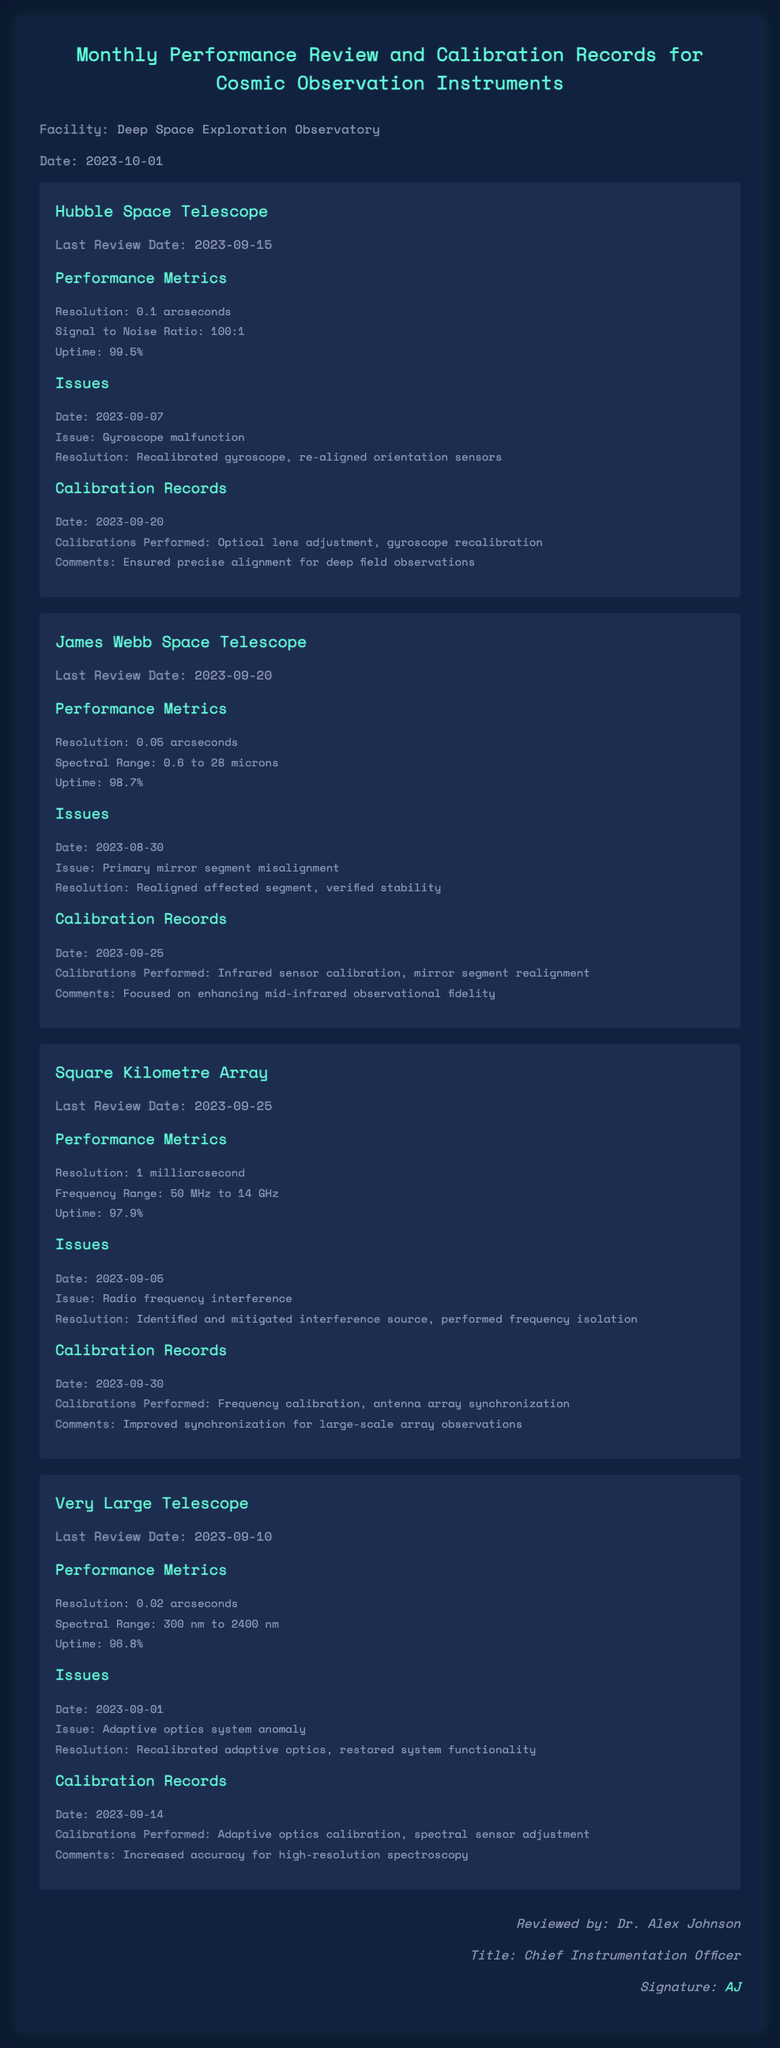What is the facility name? The facility name is explicitly mentioned at the beginning of the document.
Answer: Deep Space Exploration Observatory What is the uptime percentage of the Hubble Space Telescope? The uptime percentage is provided in the performance metrics section for the Hubble Space Telescope.
Answer: 99.5% What issue was reported for the James Webb Space Telescope? The issue reported is listed under the issues section for the James Webb Space Telescope.
Answer: Primary mirror segment misalignment What date was the calibration performed for the Very Large Telescope? The date of calibration can be found in the calibration records section for the Very Large Telescope.
Answer: 2023-09-14 Which instrument had a resolution of 1 milliarcsecond? The resolution is included in the performance metrics of the instruments in the document.
Answer: Square Kilometre Array What calibration was performed for the Hubble Space Telescope? The calibration information can be found in the calibration records section of the Hubble Space Telescope.
Answer: Optical lens adjustment, gyroscope recalibration Who reviewed the document? The reviewer's name is mentioned at the end of the document.
Answer: Dr. Alex Johnson What was the last review date for the Square Kilometre Array? The last review date is provided in the last review date section of the document.
Answer: 2023-09-25 What performance metric is listed for the James Webb Space Telescope? The performance metrics outline various details, including resolution and spectral range.
Answer: 0.05 arcseconds 